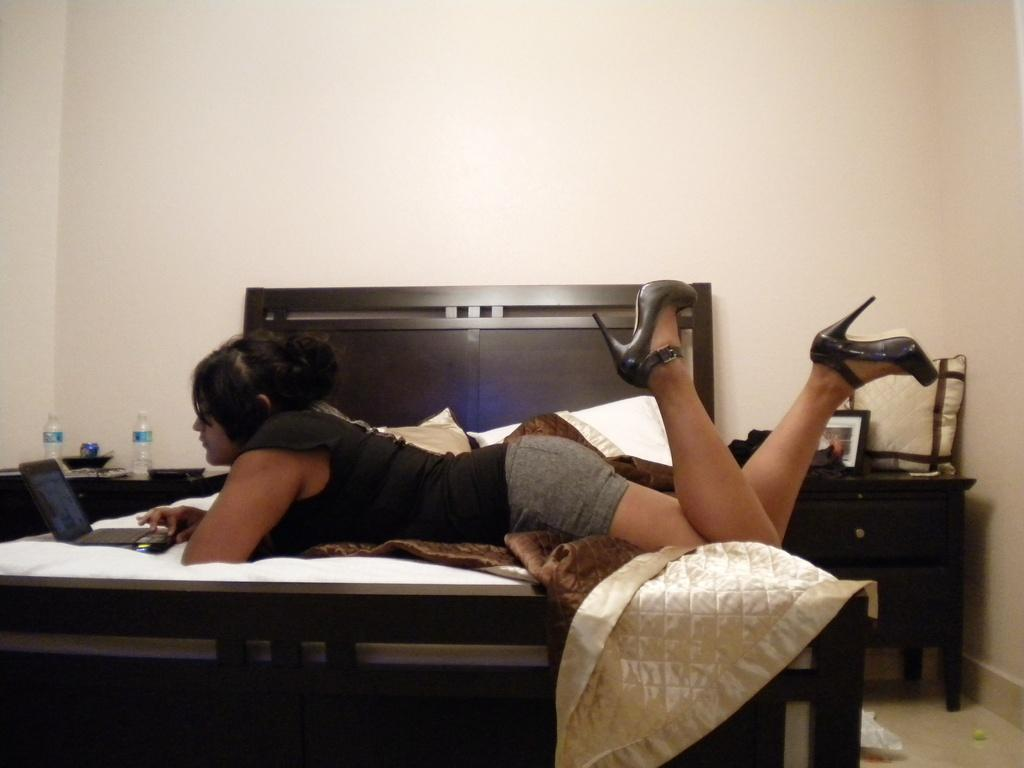What is the person in the image doing? The person is lying on the bed and operating a laptop. What can be seen on the table behind the person? There are water bottles on a table behind the person. What is the color of the wall behind the bed? The wall behind the bed is white. Where is the faucet located in the image? There is no faucet present in the image. What type of desk is the person using to operate the laptop? The person is lying on the bed and not using a desk to operate the laptop. 